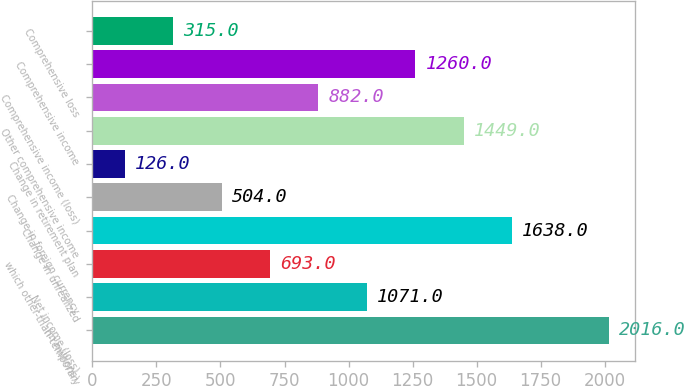Convert chart to OTSL. <chart><loc_0><loc_0><loc_500><loc_500><bar_chart><fcel>(in millions)<fcel>Net income (loss)<fcel>which other-than-temporary<fcel>Change in unrealized<fcel>Change in foreign currency<fcel>Change in retirement plan<fcel>Other comprehensive income<fcel>Comprehensive income (loss)<fcel>Comprehensive income<fcel>Comprehensive loss<nl><fcel>2016<fcel>1071<fcel>693<fcel>1638<fcel>504<fcel>126<fcel>1449<fcel>882<fcel>1260<fcel>315<nl></chart> 